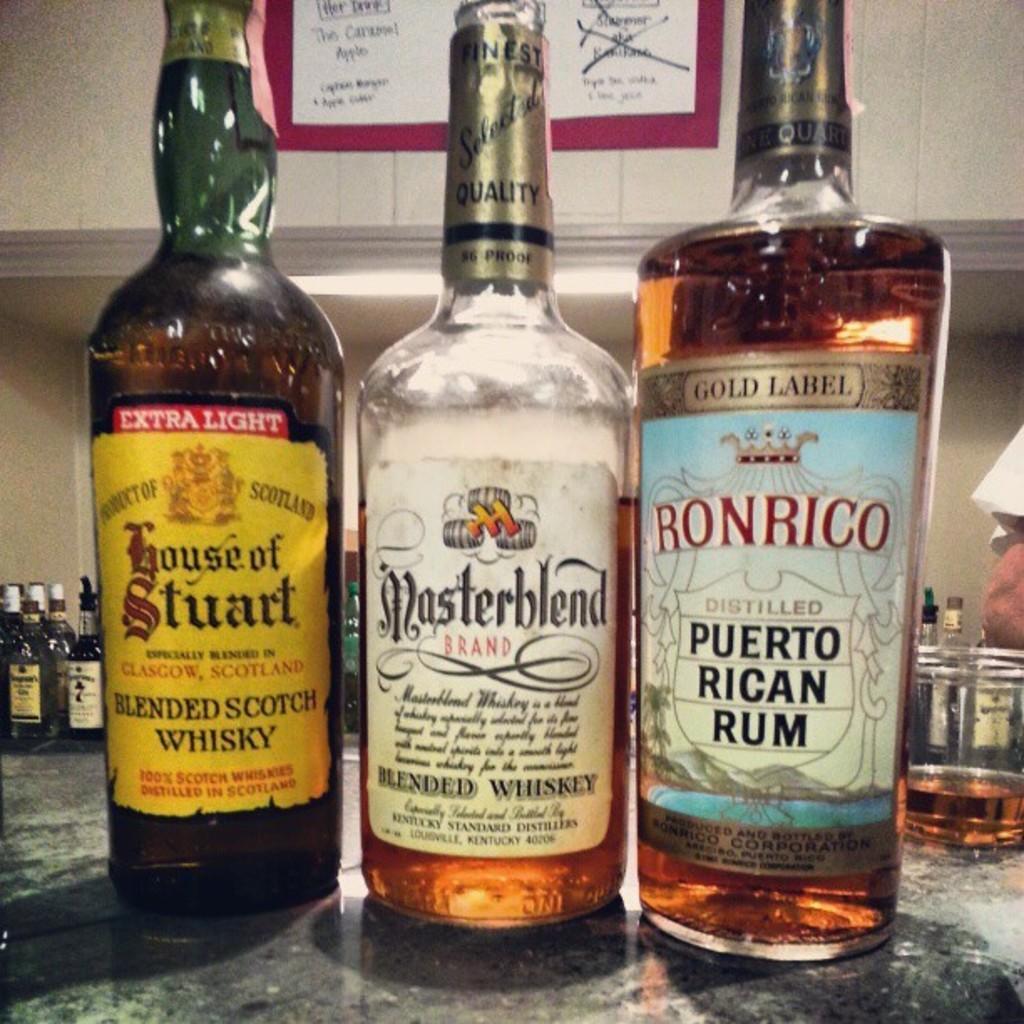Can you describe this image briefly? In this image i can see three bottles at the foreground of the image and at the background of the image there are number of bottles. 